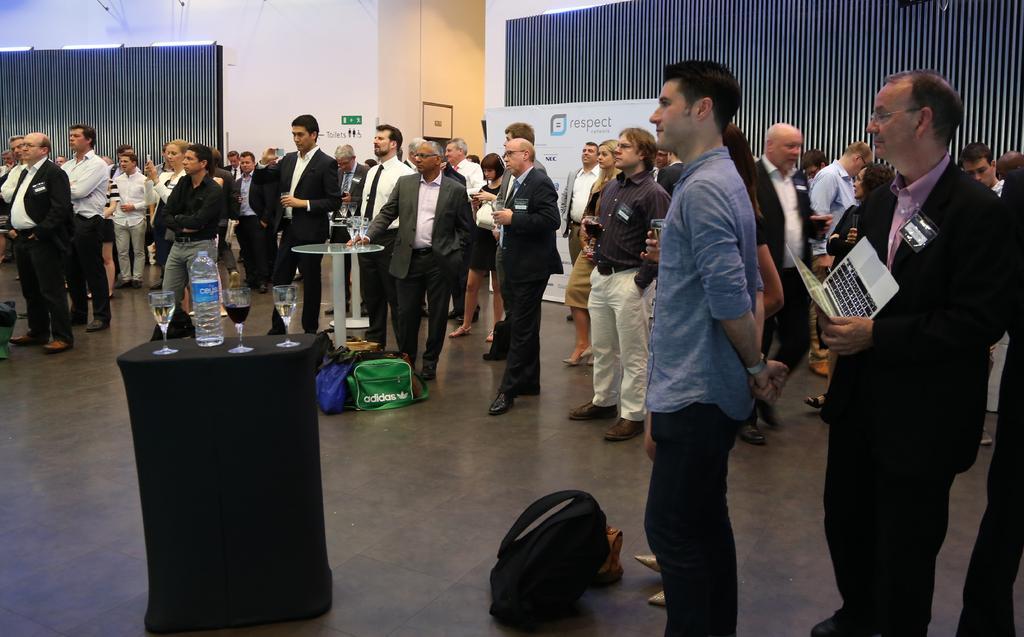Could you give a brief overview of what you see in this image? Here we can see a group of people. On these tables there are glasses and bottle. This person is holding a laptop. Far there is a signboard. Here we can see hoarding. On the floor there are bags. 